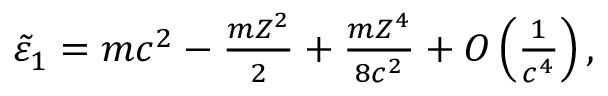Convert formula to latex. <formula><loc_0><loc_0><loc_500><loc_500>\begin{array} { r } { \tilde { \varepsilon } _ { 1 } = m c ^ { 2 } - \frac { m Z ^ { 2 } } { 2 } + \frac { m Z ^ { 4 } } { 8 c ^ { 2 } } + O \left ( \frac { 1 } { c ^ { 4 } } \right ) , } \end{array}</formula> 